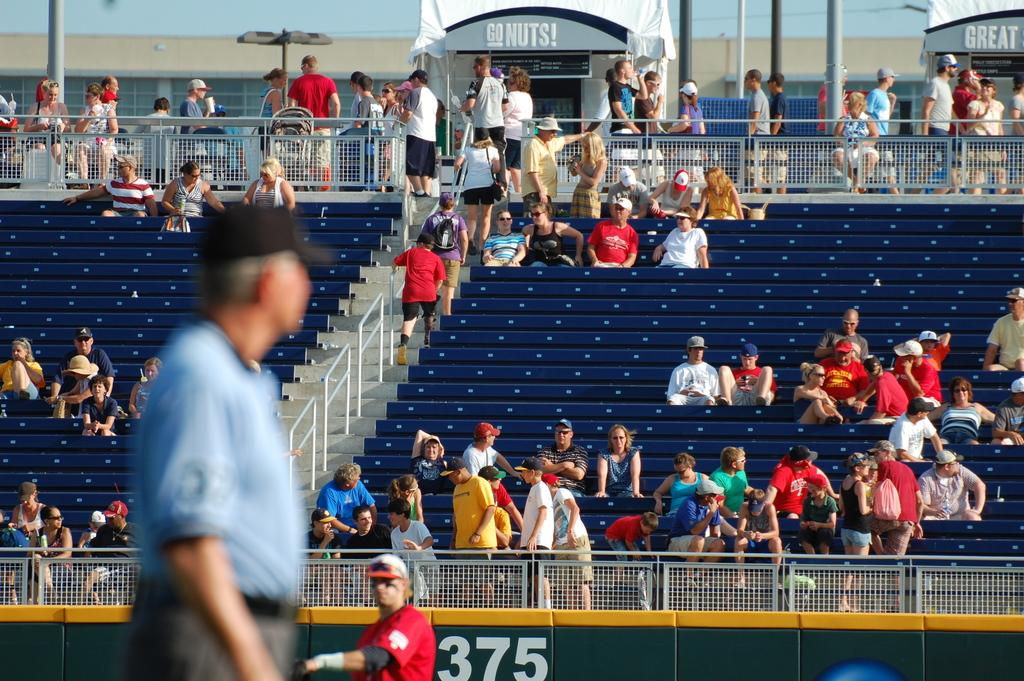What is the primary setting of the image? The primary setting of the image is a stadium. What are the people in the stadium doing? Many people are sitting, and a few are standing in the stadium. What structures can be seen in the image? There are many poles in the image. What can be seen attached to the poles? There are lights in the image. What type of beast can be seen roaming around the stadium in the image? There is no beast present in the image; the image features a stadium with people and poles with lights. 